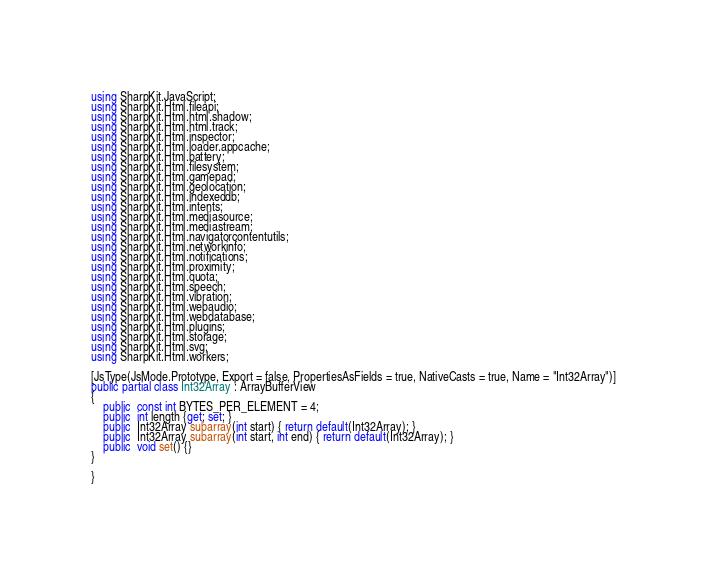<code> <loc_0><loc_0><loc_500><loc_500><_C#_>
using SharpKit.JavaScript;
using SharpKit.Html.fileapi;
using SharpKit.Html.html.shadow;
using SharpKit.Html.html.track;
using SharpKit.Html.inspector;
using SharpKit.Html.loader.appcache;
using SharpKit.Html.battery;
using SharpKit.Html.filesystem;
using SharpKit.Html.gamepad;
using SharpKit.Html.geolocation;
using SharpKit.Html.indexeddb;
using SharpKit.Html.intents;
using SharpKit.Html.mediasource;
using SharpKit.Html.mediastream;
using SharpKit.Html.navigatorcontentutils;
using SharpKit.Html.networkinfo;
using SharpKit.Html.notifications;
using SharpKit.Html.proximity;
using SharpKit.Html.quota;
using SharpKit.Html.speech;
using SharpKit.Html.vibration;
using SharpKit.Html.webaudio;
using SharpKit.Html.webdatabase;
using SharpKit.Html.plugins;
using SharpKit.Html.storage;
using SharpKit.Html.svg;
using SharpKit.Html.workers;

[JsType(JsMode.Prototype, Export = false, PropertiesAsFields = true, NativeCasts = true, Name = "Int32Array")]
public partial class Int32Array : ArrayBufferView
{
	public  const int BYTES_PER_ELEMENT = 4;
	public  int length {get; set; }
	public  Int32Array subarray(int start) { return default(Int32Array); }
	public  Int32Array subarray(int start, int end) { return default(Int32Array); }
	public  void set() {}
}

}</code> 